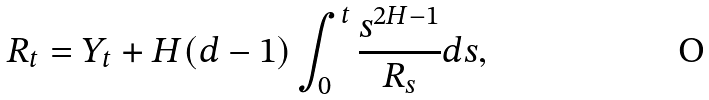Convert formula to latex. <formula><loc_0><loc_0><loc_500><loc_500>R _ { t } = Y _ { t } + H ( d - 1 ) \int _ { 0 } ^ { t } \frac { s ^ { 2 H - 1 } } { R _ { s } } d s ,</formula> 